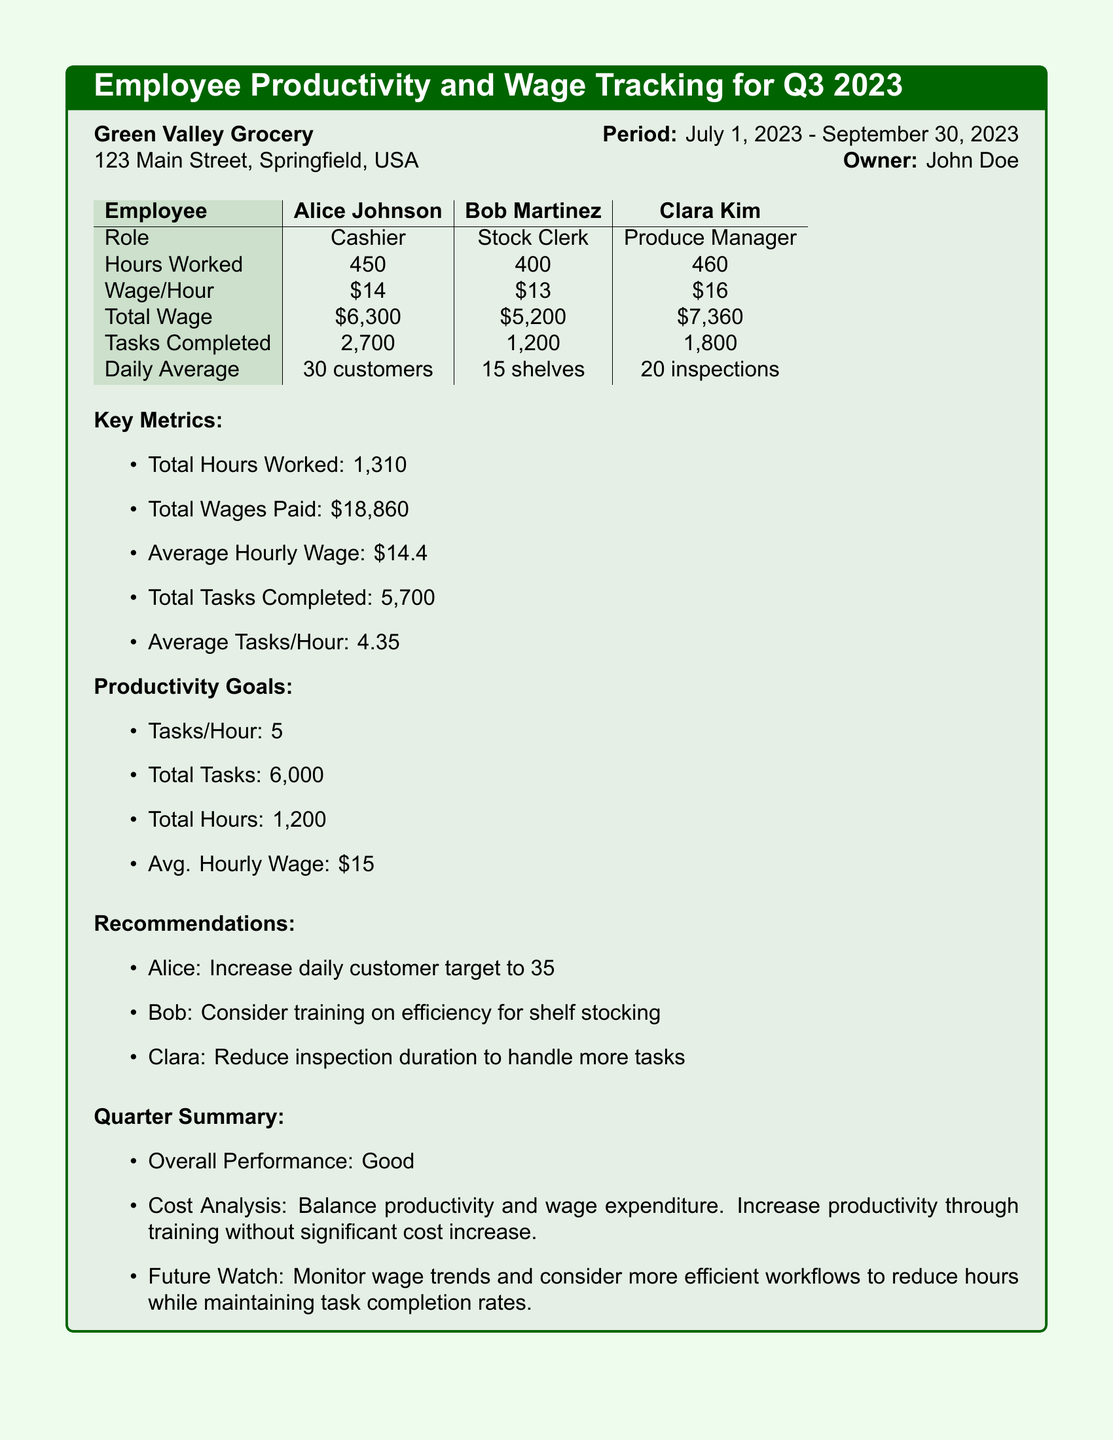What is the owner’s name? The owner's name is stated in the document as John Doe.
Answer: John Doe What is Alice's total wage? The total wage for Alice Johnson is calculated in the table as $6,300.
Answer: $6,300 How many total hours were worked? The total hours worked is the sum of all hours reported in the document, which is 450 + 400 + 460 = 1,310.
Answer: 1,310 What is the average tasks per hour? The average tasks per hour is given as 4.35 in the key metrics section.
Answer: 4.35 What is the productivity goal for tasks per hour? The productivity goal for tasks per hour is explicitly stated in the document as 5.
Answer: 5 Which employee has the highest hourly wage? The employee with the highest hourly wage is identified in the table as Clara Kim with a wage of $16/hour.
Answer: Clara Kim What is the overall performance rating for the quarter? The overall performance rating for the quarter is mentioned in the summary as Good.
Answer: Good What was Bob's role? Bob's role is listed in the table as Stock Clerk.
Answer: Stock Clerk What percentage did total wages paid amount to in comparison to the average hourly wage target? The total wages paid is $18,860 and the average hourly wage target is $15, which indicates the total wages were above the target.
Answer: Above target 